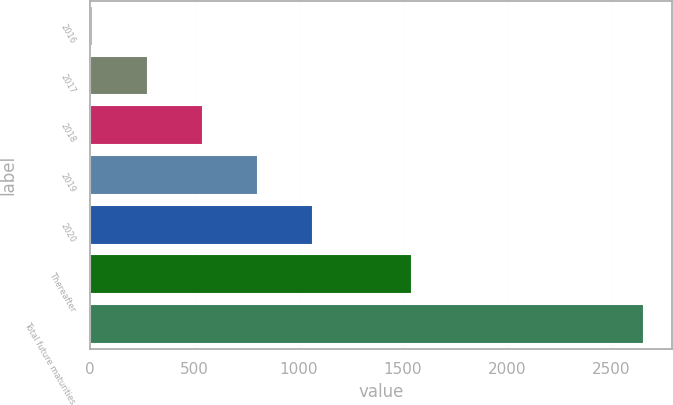<chart> <loc_0><loc_0><loc_500><loc_500><bar_chart><fcel>2016<fcel>2017<fcel>2018<fcel>2019<fcel>2020<fcel>Thereafter<fcel>Total future maturities<nl><fcel>11<fcel>275.4<fcel>539.8<fcel>804.2<fcel>1068.6<fcel>1545<fcel>2655<nl></chart> 